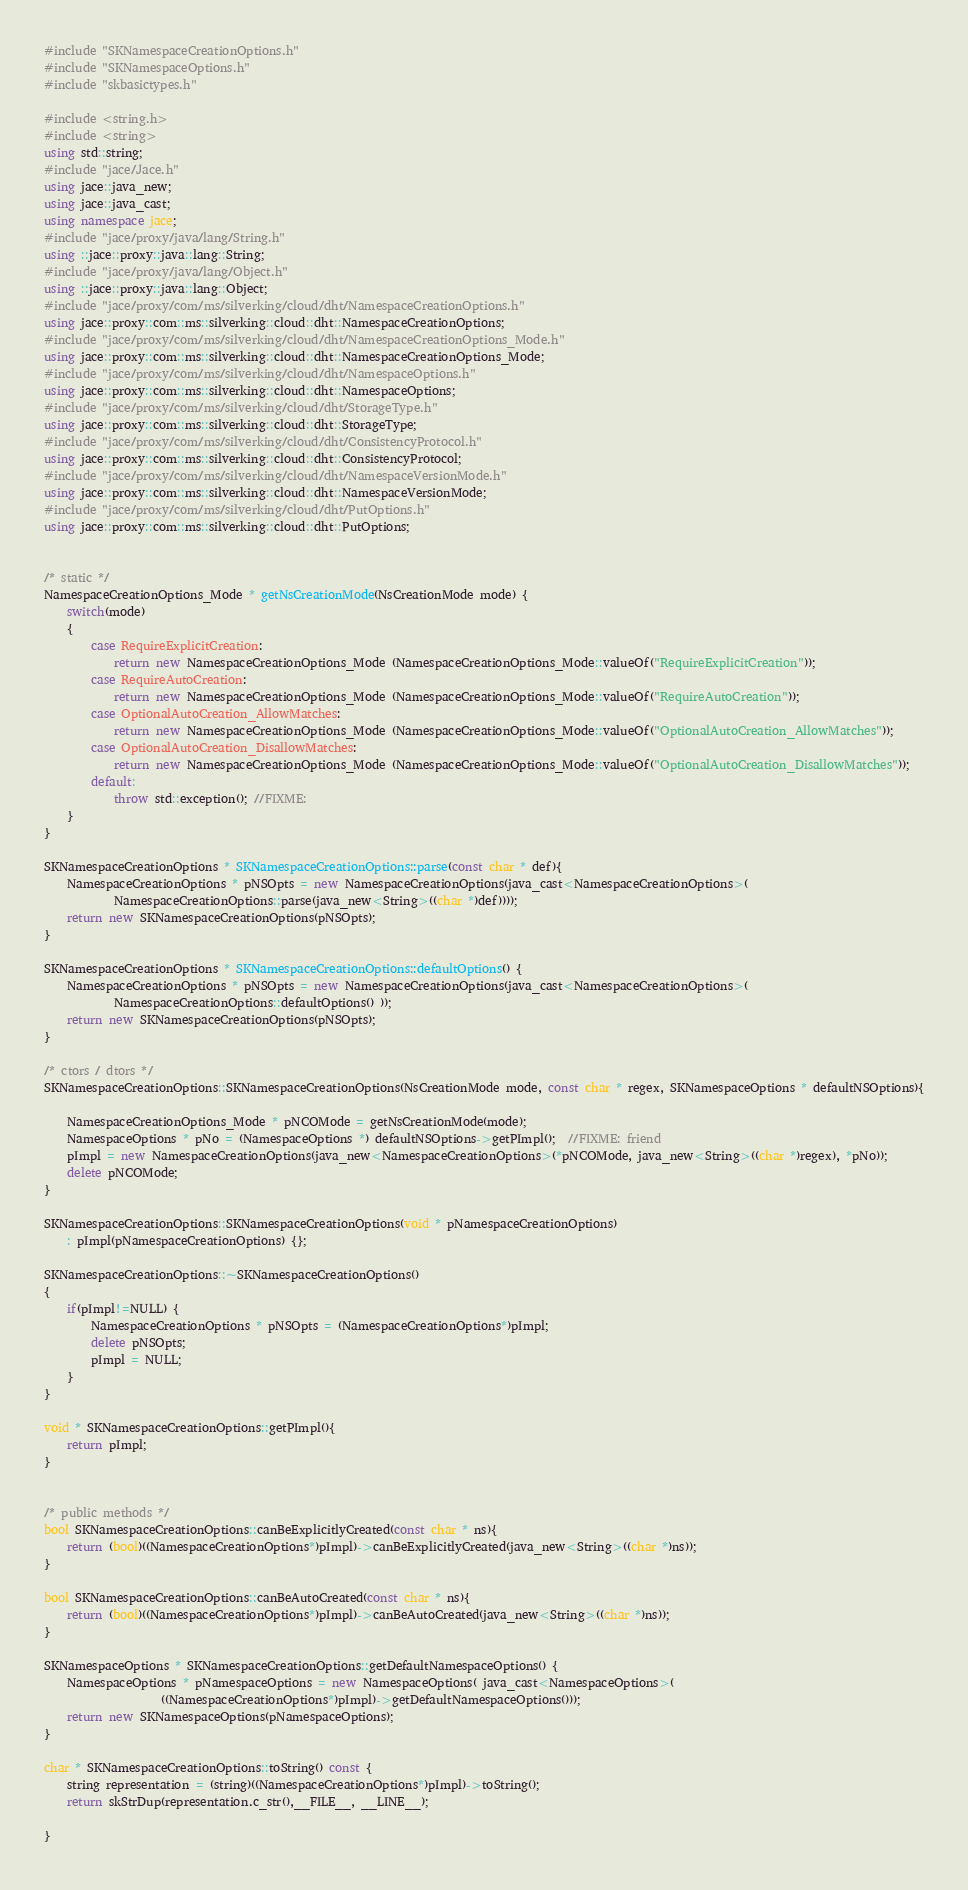Convert code to text. <code><loc_0><loc_0><loc_500><loc_500><_C++_>#include "SKNamespaceCreationOptions.h"
#include "SKNamespaceOptions.h"
#include "skbasictypes.h"

#include <string.h>
#include <string>
using std::string;
#include "jace/Jace.h"
using jace::java_new;
using jace::java_cast;
using namespace jace;
#include "jace/proxy/java/lang/String.h"
using ::jace::proxy::java::lang::String;
#include "jace/proxy/java/lang/Object.h"
using ::jace::proxy::java::lang::Object;
#include "jace/proxy/com/ms/silverking/cloud/dht/NamespaceCreationOptions.h"
using jace::proxy::com::ms::silverking::cloud::dht::NamespaceCreationOptions;
#include "jace/proxy/com/ms/silverking/cloud/dht/NamespaceCreationOptions_Mode.h"
using jace::proxy::com::ms::silverking::cloud::dht::NamespaceCreationOptions_Mode;
#include "jace/proxy/com/ms/silverking/cloud/dht/NamespaceOptions.h"
using jace::proxy::com::ms::silverking::cloud::dht::NamespaceOptions;
#include "jace/proxy/com/ms/silverking/cloud/dht/StorageType.h"
using jace::proxy::com::ms::silverking::cloud::dht::StorageType;
#include "jace/proxy/com/ms/silverking/cloud/dht/ConsistencyProtocol.h"
using jace::proxy::com::ms::silverking::cloud::dht::ConsistencyProtocol;
#include "jace/proxy/com/ms/silverking/cloud/dht/NamespaceVersionMode.h"
using jace::proxy::com::ms::silverking::cloud::dht::NamespaceVersionMode;
#include "jace/proxy/com/ms/silverking/cloud/dht/PutOptions.h"
using jace::proxy::com::ms::silverking::cloud::dht::PutOptions;


/* static */
NamespaceCreationOptions_Mode * getNsCreationMode(NsCreationMode mode) {
	switch(mode)
	{
		case RequireExplicitCreation: 
			return new NamespaceCreationOptions_Mode (NamespaceCreationOptions_Mode::valueOf("RequireExplicitCreation"));
		case RequireAutoCreation: 
			return new NamespaceCreationOptions_Mode (NamespaceCreationOptions_Mode::valueOf("RequireAutoCreation"));
		case OptionalAutoCreation_AllowMatches: 
			return new NamespaceCreationOptions_Mode (NamespaceCreationOptions_Mode::valueOf("OptionalAutoCreation_AllowMatches"));
		case OptionalAutoCreation_DisallowMatches: 
			return new NamespaceCreationOptions_Mode (NamespaceCreationOptions_Mode::valueOf("OptionalAutoCreation_DisallowMatches"));
		default: 
			throw std::exception(); //FIXME:
	}
}

SKNamespaceCreationOptions * SKNamespaceCreationOptions::parse(const char * def){
	NamespaceCreationOptions * pNSOpts = new NamespaceCreationOptions(java_cast<NamespaceCreationOptions>(
			NamespaceCreationOptions::parse(java_new<String>((char *)def))));
	return new SKNamespaceCreationOptions(pNSOpts);
}

SKNamespaceCreationOptions * SKNamespaceCreationOptions::defaultOptions() {
	NamespaceCreationOptions * pNSOpts = new NamespaceCreationOptions(java_cast<NamespaceCreationOptions>(
			NamespaceCreationOptions::defaultOptions() ));
	return new SKNamespaceCreationOptions(pNSOpts);
}

/* ctors / dtors */
SKNamespaceCreationOptions::SKNamespaceCreationOptions(NsCreationMode mode, const char * regex, SKNamespaceOptions * defaultNSOptions){

	NamespaceCreationOptions_Mode * pNCOMode = getNsCreationMode(mode);
	NamespaceOptions * pNo = (NamespaceOptions *) defaultNSOptions->getPImpl();  //FIXME: friend
	pImpl = new NamespaceCreationOptions(java_new<NamespaceCreationOptions>(*pNCOMode, java_new<String>((char *)regex), *pNo)); 
	delete pNCOMode;
}

SKNamespaceCreationOptions::SKNamespaceCreationOptions(void * pNamespaceCreationOptions)
	: pImpl(pNamespaceCreationOptions) {}; 
	
SKNamespaceCreationOptions::~SKNamespaceCreationOptions()
{
	if(pImpl!=NULL) {
		NamespaceCreationOptions * pNSOpts = (NamespaceCreationOptions*)pImpl;
		delete pNSOpts; 
		pImpl = NULL;
	}
}

void * SKNamespaceCreationOptions::getPImpl(){
	return pImpl;
}


/* public methods */
bool SKNamespaceCreationOptions::canBeExplicitlyCreated(const char * ns){
	return (bool)((NamespaceCreationOptions*)pImpl)->canBeExplicitlyCreated(java_new<String>((char *)ns)); 
}

bool SKNamespaceCreationOptions::canBeAutoCreated(const char * ns){
	return (bool)((NamespaceCreationOptions*)pImpl)->canBeAutoCreated(java_new<String>((char *)ns)); 
}

SKNamespaceOptions * SKNamespaceCreationOptions::getDefaultNamespaceOptions() {
	NamespaceOptions * pNamespaceOptions = new NamespaceOptions( java_cast<NamespaceOptions>(
					((NamespaceCreationOptions*)pImpl)->getDefaultNamespaceOptions())); 
	return new SKNamespaceOptions(pNamespaceOptions);
}

char * SKNamespaceCreationOptions::toString() const {
	string representation = (string)((NamespaceCreationOptions*)pImpl)->toString(); 
	return skStrDup(representation.c_str(),__FILE__, __LINE__);
	
}

</code> 